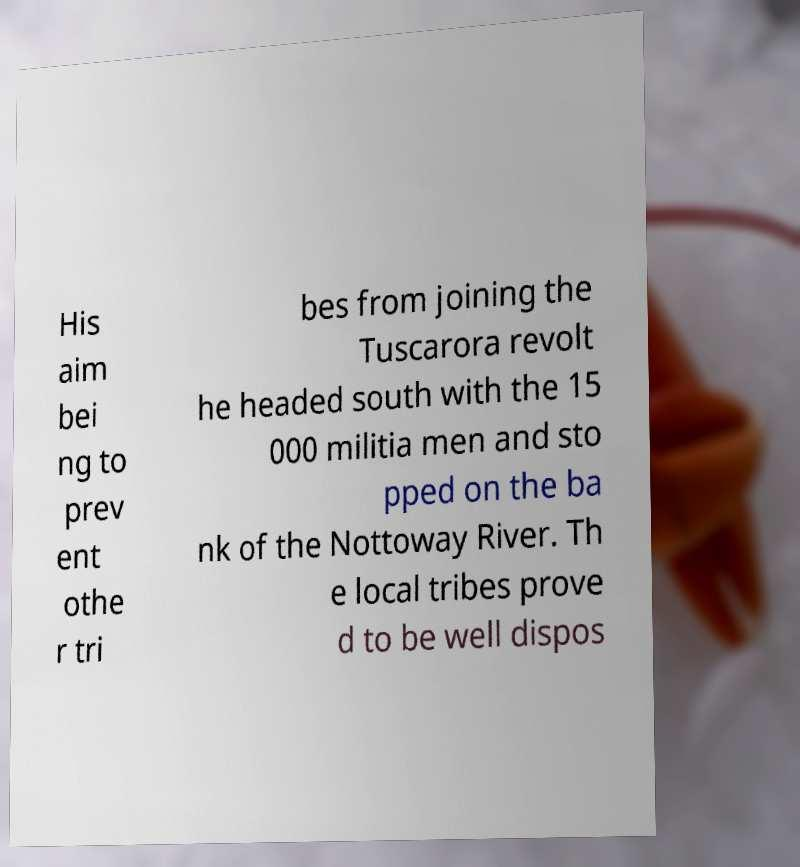Can you read and provide the text displayed in the image?This photo seems to have some interesting text. Can you extract and type it out for me? His aim bei ng to prev ent othe r tri bes from joining the Tuscarora revolt he headed south with the 15 000 militia men and sto pped on the ba nk of the Nottoway River. Th e local tribes prove d to be well dispos 